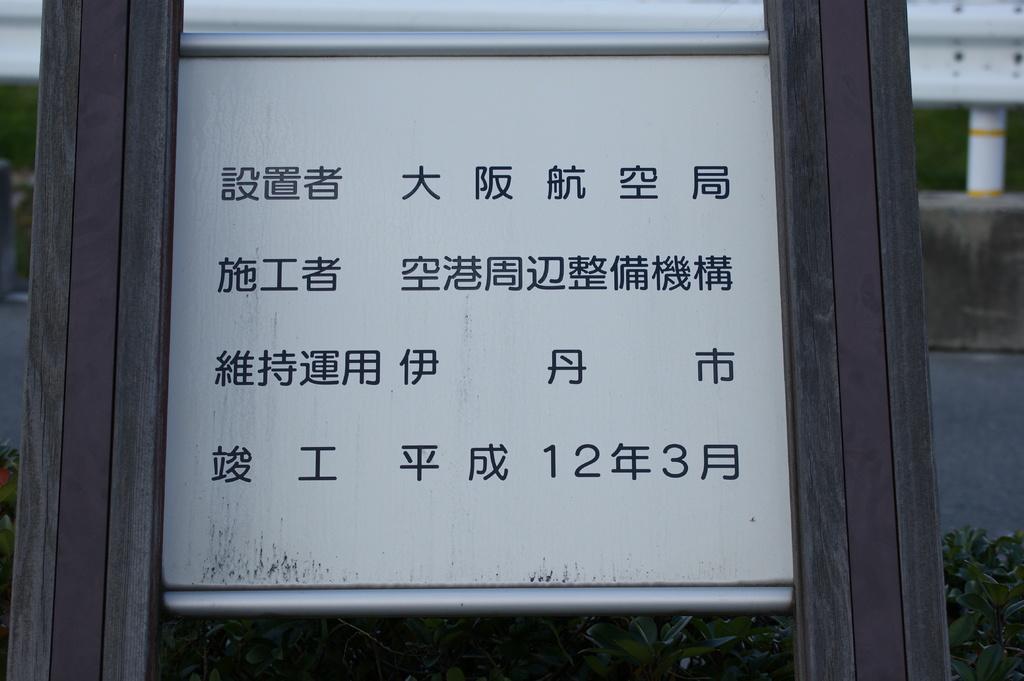Describe this image in one or two sentences. In the image we can see the white board with two wooden poles. Here we can see grass, road and the background is slightly blurred. 